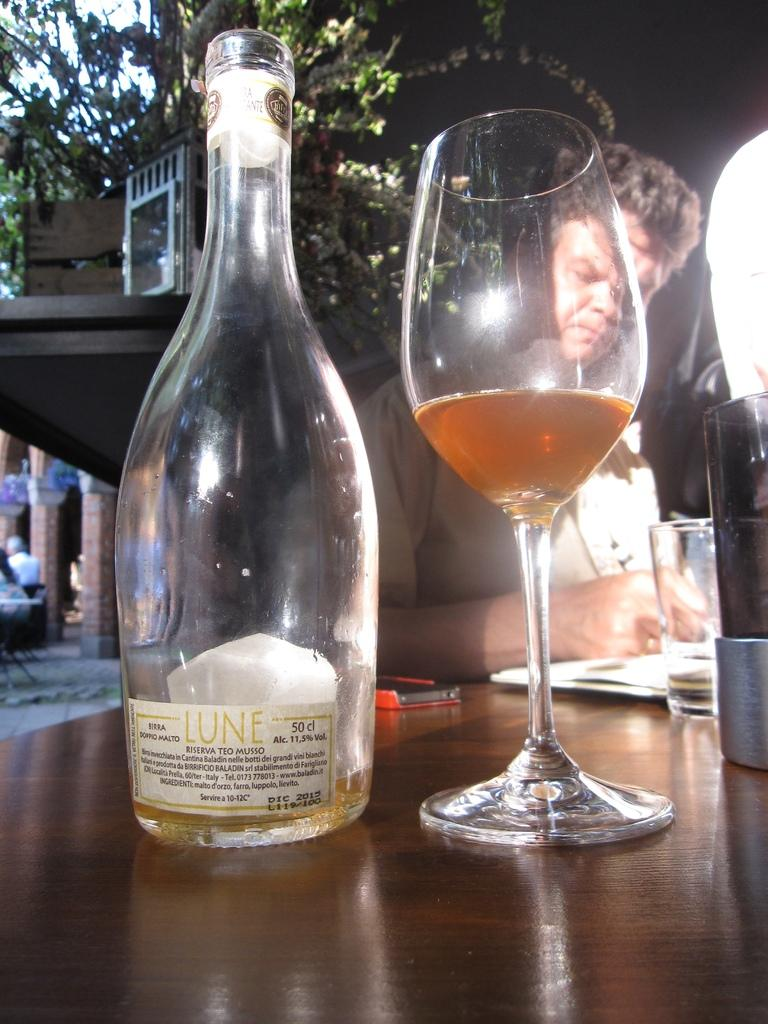What objects are on the table in the image? There is a bottle, a glass, and a mobile on the table in the image. What is the person in the image doing? The person is writing on a paper. What can be seen in the background of the image? There is a building, trees, and pillars in the background. What type of nail is being used by the person in the image? There is no nail present in the image; the person is writing on a paper. Can you tell me how many flights are visible in the image? There are no flights visible in the image; it features a table with objects and a person writing on a paper. 